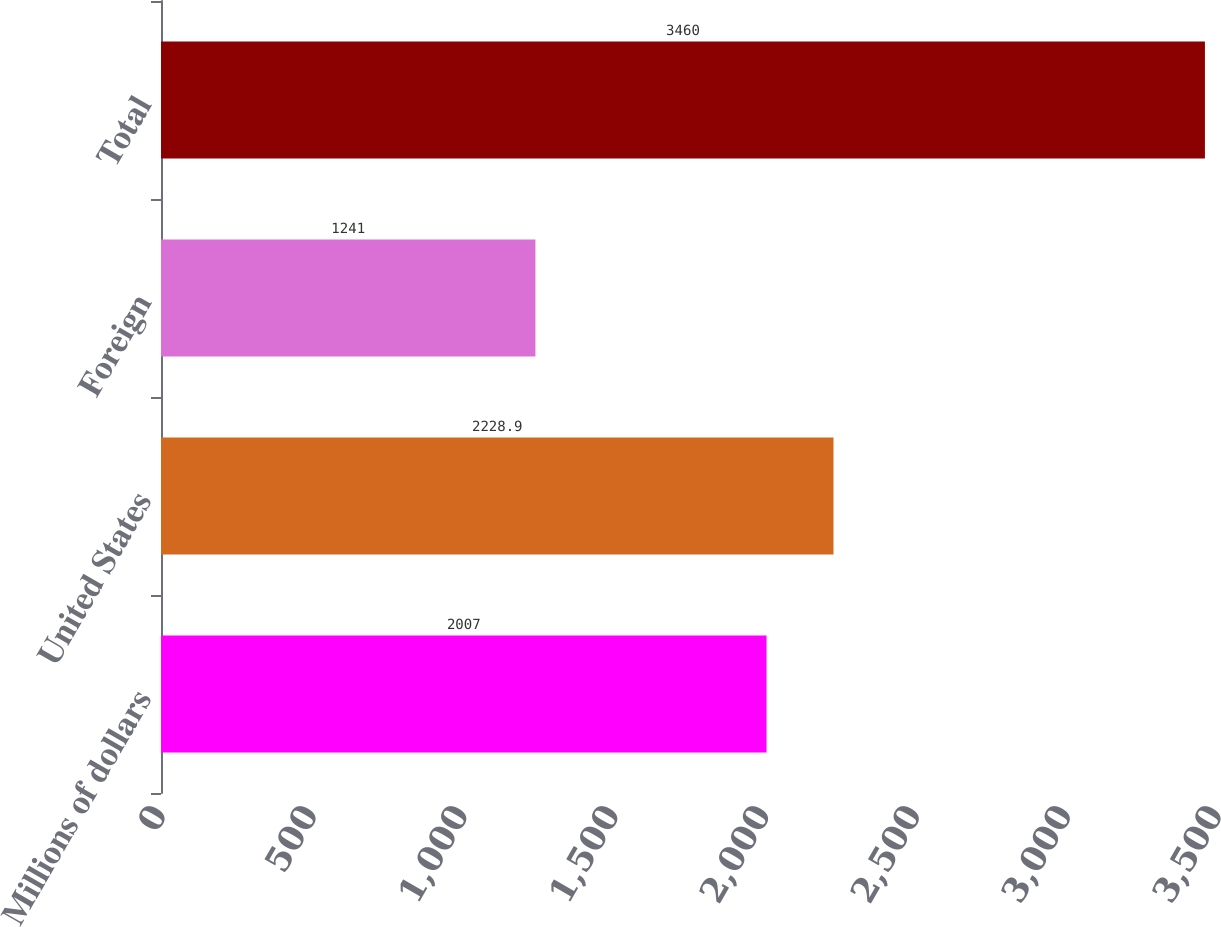Convert chart. <chart><loc_0><loc_0><loc_500><loc_500><bar_chart><fcel>Millions of dollars<fcel>United States<fcel>Foreign<fcel>Total<nl><fcel>2007<fcel>2228.9<fcel>1241<fcel>3460<nl></chart> 